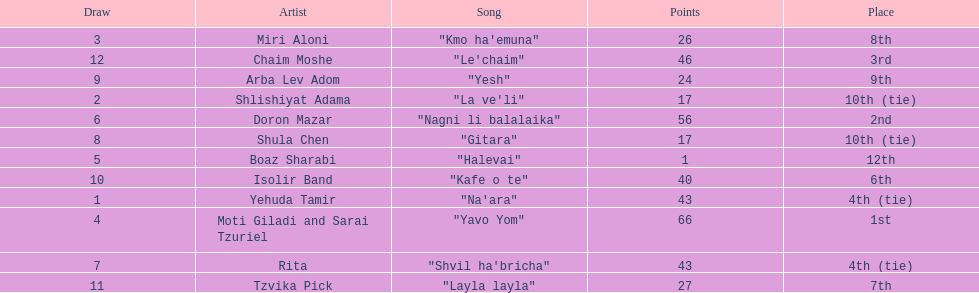How many points does the artist rita have? 43. 